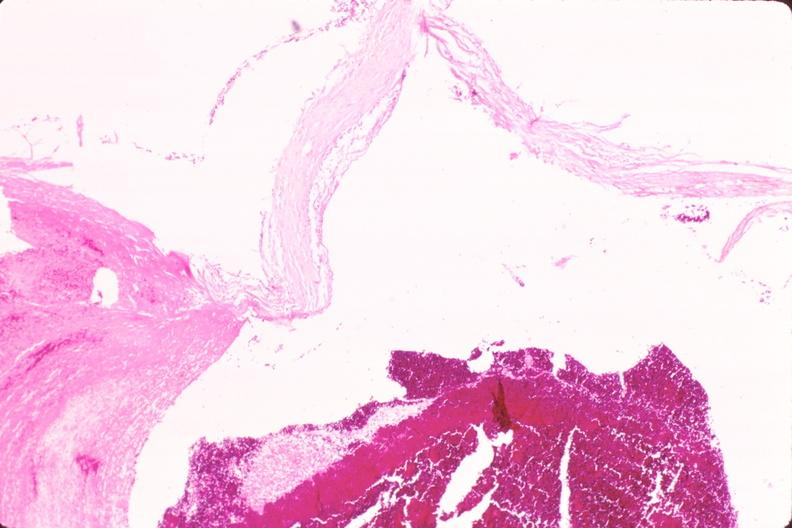what does this image show?
Answer the question using a single word or phrase. Ruptured saccular aneurysm right middle cerebral artery 